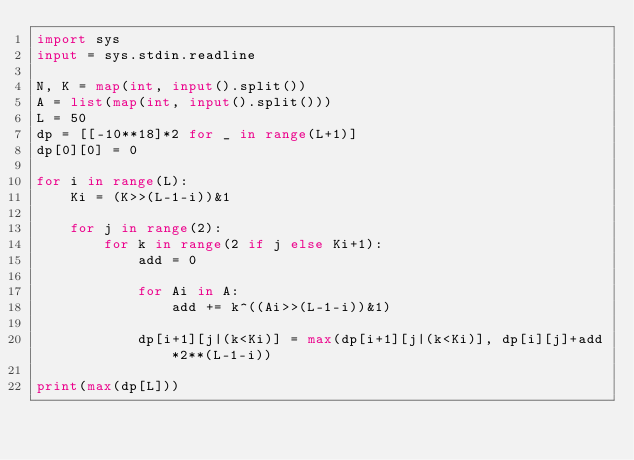<code> <loc_0><loc_0><loc_500><loc_500><_Python_>import sys
input = sys.stdin.readline

N, K = map(int, input().split())
A = list(map(int, input().split()))
L = 50
dp = [[-10**18]*2 for _ in range(L+1)]
dp[0][0] = 0

for i in range(L):
    Ki = (K>>(L-1-i))&1
    
    for j in range(2):
        for k in range(2 if j else Ki+1):
            add = 0
            
            for Ai in A:
                add += k^((Ai>>(L-1-i))&1)
            
            dp[i+1][j|(k<Ki)] = max(dp[i+1][j|(k<Ki)], dp[i][j]+add*2**(L-1-i))
            
print(max(dp[L]))</code> 